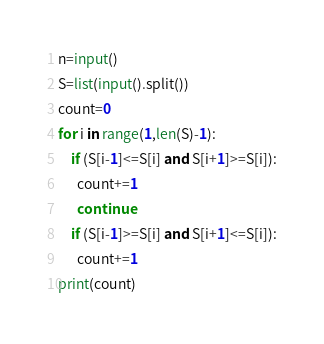Convert code to text. <code><loc_0><loc_0><loc_500><loc_500><_Python_>n=input()
S=list(input().split())
count=0
for i in range(1,len(S)-1):
    if (S[i-1]<=S[i] and S[i+1]>=S[i]):
      count+=1
      continue
    if (S[i-1]>=S[i] and S[i+1]<=S[i]):
      count+=1
print(count)</code> 